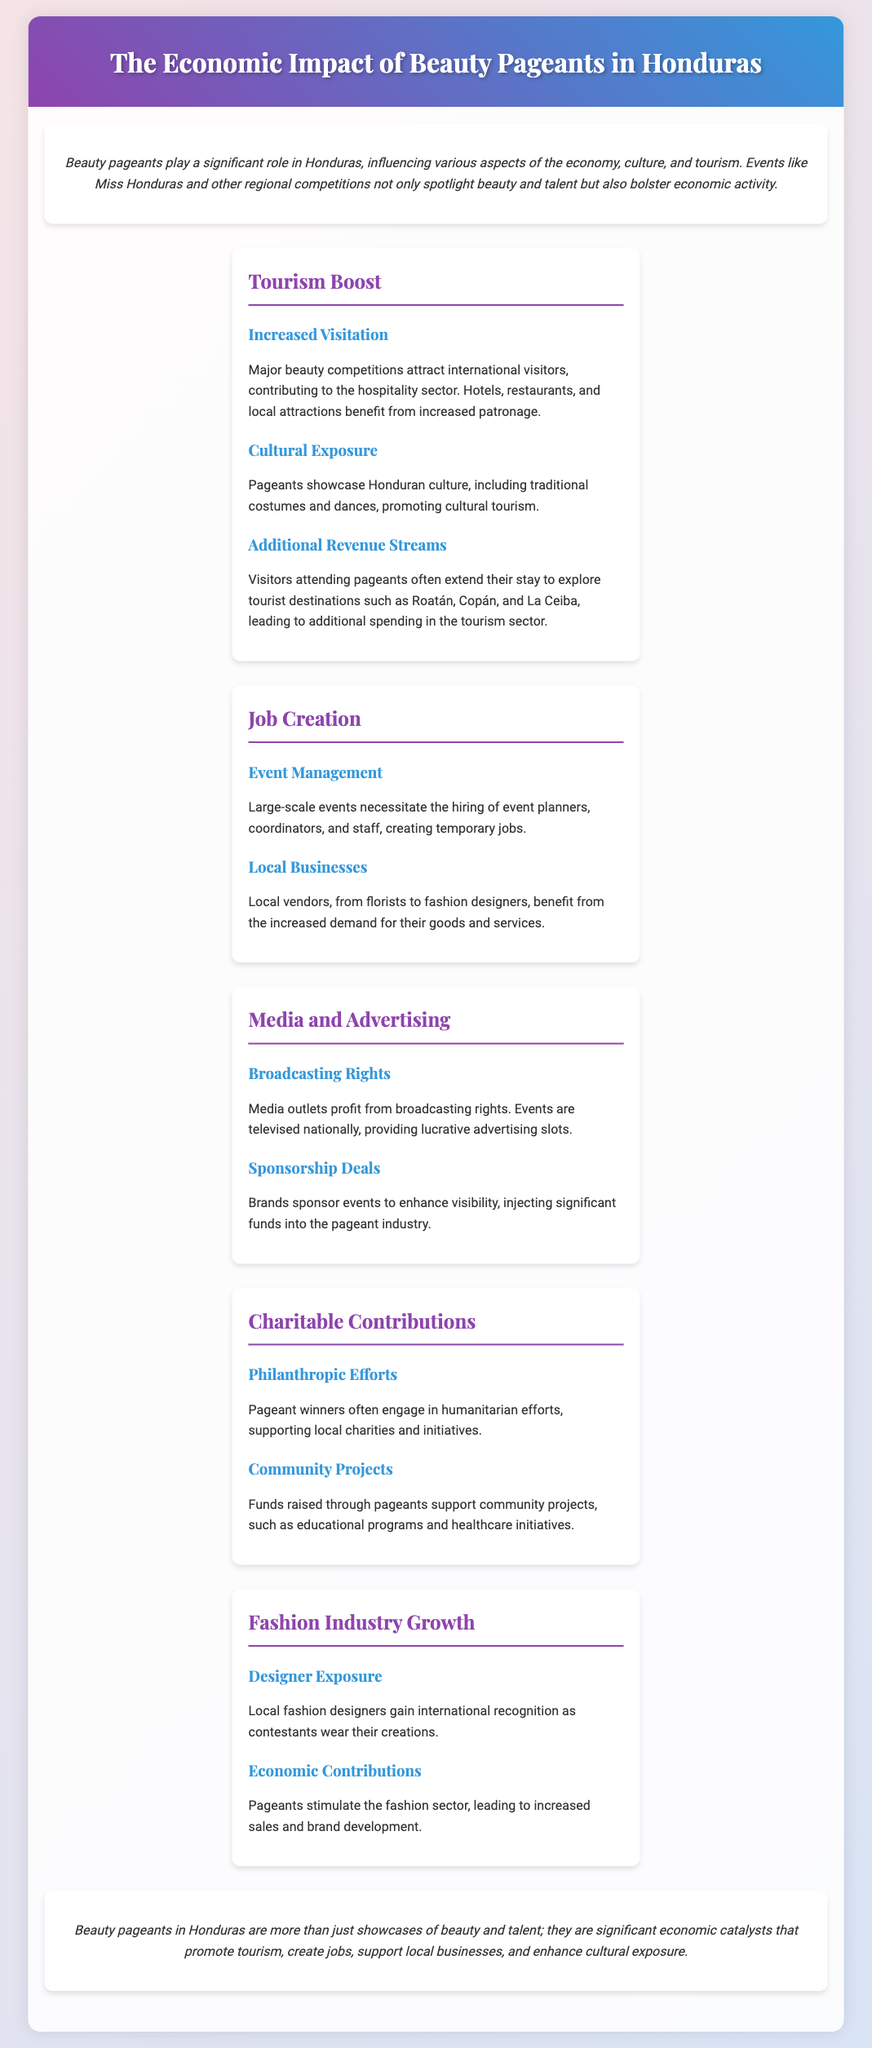What is the main role of beauty pageants in Honduras? The main role of beauty pageants in Honduras is to influence various aspects of the economy, culture, and tourism.
Answer: Influencing economy, culture, and tourism What are the three benefits of increased visitation due to beauty pageants? The three benefits include increased patronage of hotels, restaurants, and local attractions.
Answer: Increased patronage What type of jobs are created by large-scale beauty pageants? Large-scale beauty pageants create temporary jobs in event management, such as event planners and coordinators.
Answer: Temporary jobs in event management How do media outlets benefit from beauty pageants? Media outlets profit from broadcasting rights, providing lucrative advertising slots during televised events.
Answer: Broadcasting rights and advertising slots What philanthropic efforts are commonly associated with pageant winners? Pageant winners often engage in humanitarian efforts and support local charities and initiatives.
Answer: Humanitarian efforts and local charities Which sector experiences growth due to exposure from beauty pageants? The fashion industry experiences growth as local designers gain international recognition.
Answer: Fashion industry What is one community project funded by beauty pageants? Funds raised through pageants support educational programs and healthcare initiatives.
Answer: Educational programs and healthcare initiatives What do brands acquire through sponsorship deals in beauty pageants? Brands acquire enhanced visibility and injection of significant funds into the pageant industry through sponsorship deals.
Answer: Enhanced visibility What impact do beauty pageants have on tourism in Honduras? Beauty pageants promote cultural tourism by showcasing Honduran culture through traditional costumes and dances.
Answer: Promote cultural tourism 